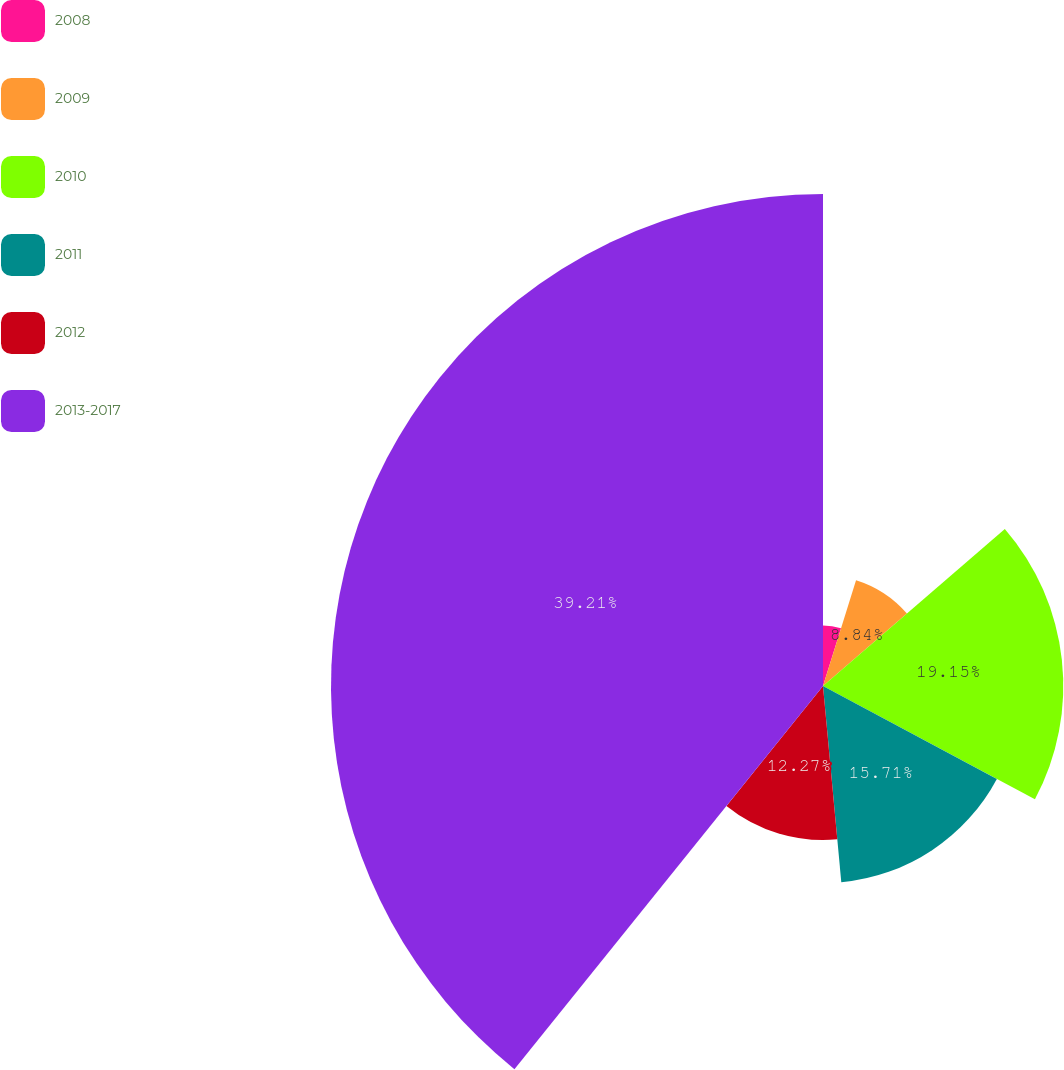Convert chart. <chart><loc_0><loc_0><loc_500><loc_500><pie_chart><fcel>2008<fcel>2009<fcel>2010<fcel>2011<fcel>2012<fcel>2013-2017<nl><fcel>4.82%<fcel>8.84%<fcel>19.15%<fcel>15.71%<fcel>12.27%<fcel>39.21%<nl></chart> 